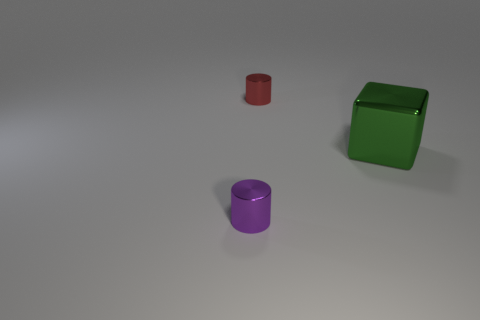Add 1 cyan rubber spheres. How many objects exist? 4 Subtract 1 blocks. How many blocks are left? 0 Subtract 0 blue cylinders. How many objects are left? 3 Subtract all cubes. How many objects are left? 2 Subtract all yellow cylinders. Subtract all red blocks. How many cylinders are left? 2 Subtract all green balls. How many red cylinders are left? 1 Subtract all large cyan rubber cylinders. Subtract all big things. How many objects are left? 2 Add 1 red metallic cylinders. How many red metallic cylinders are left? 2 Add 2 cubes. How many cubes exist? 3 